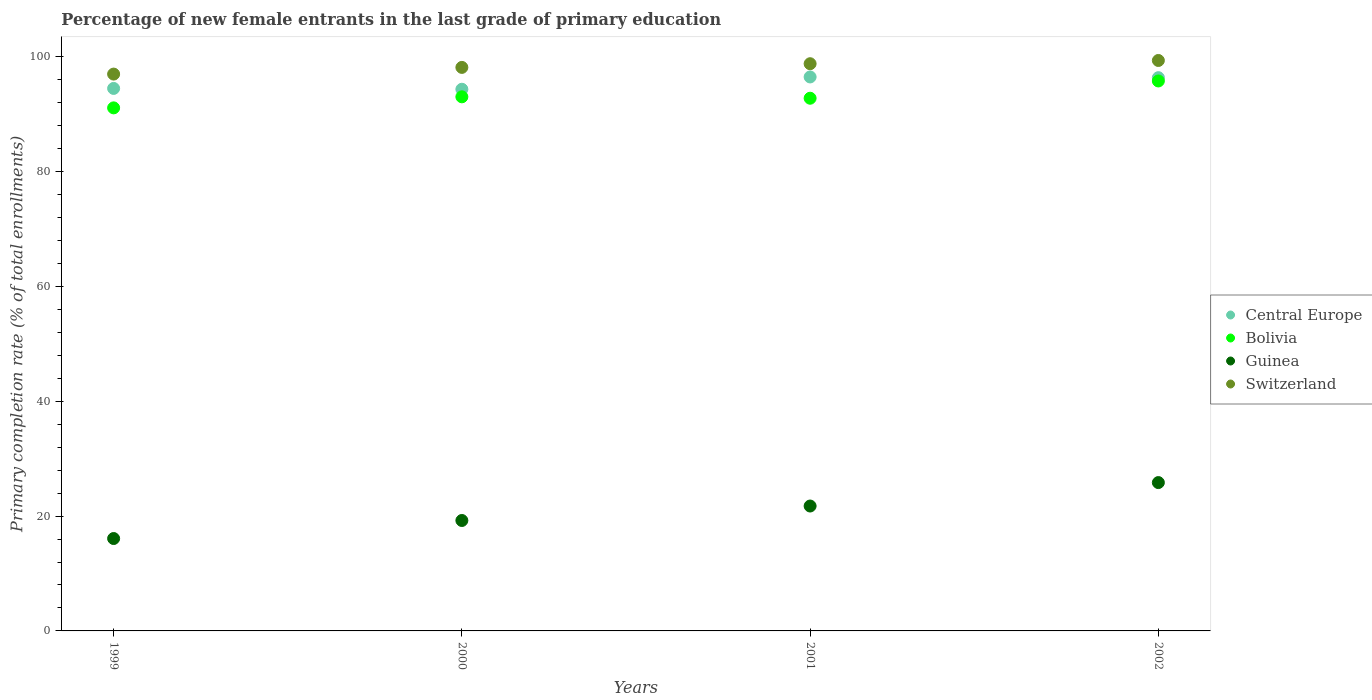What is the percentage of new female entrants in Guinea in 2001?
Provide a succinct answer. 21.75. Across all years, what is the maximum percentage of new female entrants in Guinea?
Keep it short and to the point. 25.84. Across all years, what is the minimum percentage of new female entrants in Switzerland?
Ensure brevity in your answer.  96.99. In which year was the percentage of new female entrants in Switzerland maximum?
Your answer should be very brief. 2002. In which year was the percentage of new female entrants in Guinea minimum?
Your answer should be very brief. 1999. What is the total percentage of new female entrants in Bolivia in the graph?
Give a very brief answer. 372.7. What is the difference between the percentage of new female entrants in Guinea in 1999 and that in 2001?
Your answer should be very brief. -5.66. What is the difference between the percentage of new female entrants in Bolivia in 2002 and the percentage of new female entrants in Guinea in 2000?
Your answer should be compact. 76.56. What is the average percentage of new female entrants in Bolivia per year?
Ensure brevity in your answer.  93.18. In the year 2002, what is the difference between the percentage of new female entrants in Bolivia and percentage of new female entrants in Guinea?
Make the answer very short. 69.95. In how many years, is the percentage of new female entrants in Central Europe greater than 72 %?
Offer a terse response. 4. What is the ratio of the percentage of new female entrants in Bolivia in 1999 to that in 2000?
Provide a succinct answer. 0.98. Is the difference between the percentage of new female entrants in Bolivia in 1999 and 2002 greater than the difference between the percentage of new female entrants in Guinea in 1999 and 2002?
Offer a terse response. Yes. What is the difference between the highest and the second highest percentage of new female entrants in Central Europe?
Your answer should be very brief. 0.13. What is the difference between the highest and the lowest percentage of new female entrants in Guinea?
Offer a very short reply. 9.74. In how many years, is the percentage of new female entrants in Switzerland greater than the average percentage of new female entrants in Switzerland taken over all years?
Your answer should be very brief. 2. Is the sum of the percentage of new female entrants in Bolivia in 2001 and 2002 greater than the maximum percentage of new female entrants in Central Europe across all years?
Offer a very short reply. Yes. Is the percentage of new female entrants in Bolivia strictly greater than the percentage of new female entrants in Switzerland over the years?
Offer a terse response. No. Is the percentage of new female entrants in Switzerland strictly less than the percentage of new female entrants in Guinea over the years?
Offer a very short reply. No. Does the graph contain grids?
Keep it short and to the point. No. What is the title of the graph?
Your answer should be very brief. Percentage of new female entrants in the last grade of primary education. What is the label or title of the X-axis?
Provide a succinct answer. Years. What is the label or title of the Y-axis?
Offer a terse response. Primary completion rate (% of total enrollments). What is the Primary completion rate (% of total enrollments) of Central Europe in 1999?
Provide a short and direct response. 94.49. What is the Primary completion rate (% of total enrollments) of Bolivia in 1999?
Your answer should be very brief. 91.1. What is the Primary completion rate (% of total enrollments) in Guinea in 1999?
Give a very brief answer. 16.09. What is the Primary completion rate (% of total enrollments) in Switzerland in 1999?
Make the answer very short. 96.99. What is the Primary completion rate (% of total enrollments) in Central Europe in 2000?
Provide a succinct answer. 94.35. What is the Primary completion rate (% of total enrollments) of Bolivia in 2000?
Your answer should be compact. 93.03. What is the Primary completion rate (% of total enrollments) of Guinea in 2000?
Ensure brevity in your answer.  19.23. What is the Primary completion rate (% of total enrollments) in Switzerland in 2000?
Provide a succinct answer. 98.15. What is the Primary completion rate (% of total enrollments) in Central Europe in 2001?
Provide a succinct answer. 96.49. What is the Primary completion rate (% of total enrollments) in Bolivia in 2001?
Your answer should be very brief. 92.78. What is the Primary completion rate (% of total enrollments) of Guinea in 2001?
Your response must be concise. 21.75. What is the Primary completion rate (% of total enrollments) of Switzerland in 2001?
Give a very brief answer. 98.79. What is the Primary completion rate (% of total enrollments) of Central Europe in 2002?
Provide a short and direct response. 96.36. What is the Primary completion rate (% of total enrollments) of Bolivia in 2002?
Make the answer very short. 95.79. What is the Primary completion rate (% of total enrollments) of Guinea in 2002?
Keep it short and to the point. 25.84. What is the Primary completion rate (% of total enrollments) of Switzerland in 2002?
Ensure brevity in your answer.  99.36. Across all years, what is the maximum Primary completion rate (% of total enrollments) in Central Europe?
Ensure brevity in your answer.  96.49. Across all years, what is the maximum Primary completion rate (% of total enrollments) of Bolivia?
Give a very brief answer. 95.79. Across all years, what is the maximum Primary completion rate (% of total enrollments) of Guinea?
Provide a succinct answer. 25.84. Across all years, what is the maximum Primary completion rate (% of total enrollments) in Switzerland?
Provide a succinct answer. 99.36. Across all years, what is the minimum Primary completion rate (% of total enrollments) in Central Europe?
Your response must be concise. 94.35. Across all years, what is the minimum Primary completion rate (% of total enrollments) of Bolivia?
Make the answer very short. 91.1. Across all years, what is the minimum Primary completion rate (% of total enrollments) of Guinea?
Your response must be concise. 16.09. Across all years, what is the minimum Primary completion rate (% of total enrollments) of Switzerland?
Provide a succinct answer. 96.99. What is the total Primary completion rate (% of total enrollments) of Central Europe in the graph?
Provide a short and direct response. 381.69. What is the total Primary completion rate (% of total enrollments) in Bolivia in the graph?
Ensure brevity in your answer.  372.7. What is the total Primary completion rate (% of total enrollments) in Guinea in the graph?
Your answer should be very brief. 82.92. What is the total Primary completion rate (% of total enrollments) in Switzerland in the graph?
Give a very brief answer. 393.29. What is the difference between the Primary completion rate (% of total enrollments) in Central Europe in 1999 and that in 2000?
Keep it short and to the point. 0.14. What is the difference between the Primary completion rate (% of total enrollments) of Bolivia in 1999 and that in 2000?
Your answer should be very brief. -1.93. What is the difference between the Primary completion rate (% of total enrollments) in Guinea in 1999 and that in 2000?
Keep it short and to the point. -3.14. What is the difference between the Primary completion rate (% of total enrollments) of Switzerland in 1999 and that in 2000?
Your answer should be compact. -1.16. What is the difference between the Primary completion rate (% of total enrollments) of Central Europe in 1999 and that in 2001?
Make the answer very short. -2. What is the difference between the Primary completion rate (% of total enrollments) in Bolivia in 1999 and that in 2001?
Your response must be concise. -1.68. What is the difference between the Primary completion rate (% of total enrollments) of Guinea in 1999 and that in 2001?
Offer a terse response. -5.66. What is the difference between the Primary completion rate (% of total enrollments) in Switzerland in 1999 and that in 2001?
Your response must be concise. -1.81. What is the difference between the Primary completion rate (% of total enrollments) of Central Europe in 1999 and that in 2002?
Offer a very short reply. -1.87. What is the difference between the Primary completion rate (% of total enrollments) in Bolivia in 1999 and that in 2002?
Your response must be concise. -4.69. What is the difference between the Primary completion rate (% of total enrollments) in Guinea in 1999 and that in 2002?
Your answer should be very brief. -9.74. What is the difference between the Primary completion rate (% of total enrollments) of Switzerland in 1999 and that in 2002?
Your answer should be compact. -2.37. What is the difference between the Primary completion rate (% of total enrollments) in Central Europe in 2000 and that in 2001?
Ensure brevity in your answer.  -2.14. What is the difference between the Primary completion rate (% of total enrollments) of Bolivia in 2000 and that in 2001?
Your answer should be very brief. 0.25. What is the difference between the Primary completion rate (% of total enrollments) of Guinea in 2000 and that in 2001?
Give a very brief answer. -2.52. What is the difference between the Primary completion rate (% of total enrollments) in Switzerland in 2000 and that in 2001?
Offer a terse response. -0.64. What is the difference between the Primary completion rate (% of total enrollments) in Central Europe in 2000 and that in 2002?
Make the answer very short. -2.02. What is the difference between the Primary completion rate (% of total enrollments) of Bolivia in 2000 and that in 2002?
Offer a very short reply. -2.76. What is the difference between the Primary completion rate (% of total enrollments) of Guinea in 2000 and that in 2002?
Your answer should be very brief. -6.6. What is the difference between the Primary completion rate (% of total enrollments) of Switzerland in 2000 and that in 2002?
Offer a terse response. -1.21. What is the difference between the Primary completion rate (% of total enrollments) of Central Europe in 2001 and that in 2002?
Your answer should be compact. 0.13. What is the difference between the Primary completion rate (% of total enrollments) in Bolivia in 2001 and that in 2002?
Your response must be concise. -3.01. What is the difference between the Primary completion rate (% of total enrollments) of Guinea in 2001 and that in 2002?
Give a very brief answer. -4.08. What is the difference between the Primary completion rate (% of total enrollments) of Switzerland in 2001 and that in 2002?
Offer a very short reply. -0.56. What is the difference between the Primary completion rate (% of total enrollments) in Central Europe in 1999 and the Primary completion rate (% of total enrollments) in Bolivia in 2000?
Give a very brief answer. 1.46. What is the difference between the Primary completion rate (% of total enrollments) of Central Europe in 1999 and the Primary completion rate (% of total enrollments) of Guinea in 2000?
Keep it short and to the point. 75.26. What is the difference between the Primary completion rate (% of total enrollments) in Central Europe in 1999 and the Primary completion rate (% of total enrollments) in Switzerland in 2000?
Keep it short and to the point. -3.66. What is the difference between the Primary completion rate (% of total enrollments) in Bolivia in 1999 and the Primary completion rate (% of total enrollments) in Guinea in 2000?
Ensure brevity in your answer.  71.87. What is the difference between the Primary completion rate (% of total enrollments) in Bolivia in 1999 and the Primary completion rate (% of total enrollments) in Switzerland in 2000?
Your answer should be compact. -7.05. What is the difference between the Primary completion rate (% of total enrollments) in Guinea in 1999 and the Primary completion rate (% of total enrollments) in Switzerland in 2000?
Provide a succinct answer. -82.06. What is the difference between the Primary completion rate (% of total enrollments) of Central Europe in 1999 and the Primary completion rate (% of total enrollments) of Bolivia in 2001?
Keep it short and to the point. 1.71. What is the difference between the Primary completion rate (% of total enrollments) in Central Europe in 1999 and the Primary completion rate (% of total enrollments) in Guinea in 2001?
Your response must be concise. 72.74. What is the difference between the Primary completion rate (% of total enrollments) of Central Europe in 1999 and the Primary completion rate (% of total enrollments) of Switzerland in 2001?
Offer a terse response. -4.3. What is the difference between the Primary completion rate (% of total enrollments) of Bolivia in 1999 and the Primary completion rate (% of total enrollments) of Guinea in 2001?
Offer a very short reply. 69.35. What is the difference between the Primary completion rate (% of total enrollments) in Bolivia in 1999 and the Primary completion rate (% of total enrollments) in Switzerland in 2001?
Provide a short and direct response. -7.69. What is the difference between the Primary completion rate (% of total enrollments) of Guinea in 1999 and the Primary completion rate (% of total enrollments) of Switzerland in 2001?
Your response must be concise. -82.7. What is the difference between the Primary completion rate (% of total enrollments) in Central Europe in 1999 and the Primary completion rate (% of total enrollments) in Bolivia in 2002?
Keep it short and to the point. -1.3. What is the difference between the Primary completion rate (% of total enrollments) of Central Europe in 1999 and the Primary completion rate (% of total enrollments) of Guinea in 2002?
Give a very brief answer. 68.65. What is the difference between the Primary completion rate (% of total enrollments) in Central Europe in 1999 and the Primary completion rate (% of total enrollments) in Switzerland in 2002?
Ensure brevity in your answer.  -4.87. What is the difference between the Primary completion rate (% of total enrollments) of Bolivia in 1999 and the Primary completion rate (% of total enrollments) of Guinea in 2002?
Offer a terse response. 65.27. What is the difference between the Primary completion rate (% of total enrollments) in Bolivia in 1999 and the Primary completion rate (% of total enrollments) in Switzerland in 2002?
Provide a succinct answer. -8.25. What is the difference between the Primary completion rate (% of total enrollments) in Guinea in 1999 and the Primary completion rate (% of total enrollments) in Switzerland in 2002?
Your response must be concise. -83.27. What is the difference between the Primary completion rate (% of total enrollments) of Central Europe in 2000 and the Primary completion rate (% of total enrollments) of Bolivia in 2001?
Provide a short and direct response. 1.56. What is the difference between the Primary completion rate (% of total enrollments) of Central Europe in 2000 and the Primary completion rate (% of total enrollments) of Guinea in 2001?
Provide a short and direct response. 72.59. What is the difference between the Primary completion rate (% of total enrollments) in Central Europe in 2000 and the Primary completion rate (% of total enrollments) in Switzerland in 2001?
Make the answer very short. -4.45. What is the difference between the Primary completion rate (% of total enrollments) in Bolivia in 2000 and the Primary completion rate (% of total enrollments) in Guinea in 2001?
Your response must be concise. 71.27. What is the difference between the Primary completion rate (% of total enrollments) in Bolivia in 2000 and the Primary completion rate (% of total enrollments) in Switzerland in 2001?
Your answer should be compact. -5.77. What is the difference between the Primary completion rate (% of total enrollments) of Guinea in 2000 and the Primary completion rate (% of total enrollments) of Switzerland in 2001?
Keep it short and to the point. -79.56. What is the difference between the Primary completion rate (% of total enrollments) of Central Europe in 2000 and the Primary completion rate (% of total enrollments) of Bolivia in 2002?
Keep it short and to the point. -1.44. What is the difference between the Primary completion rate (% of total enrollments) in Central Europe in 2000 and the Primary completion rate (% of total enrollments) in Guinea in 2002?
Your answer should be compact. 68.51. What is the difference between the Primary completion rate (% of total enrollments) in Central Europe in 2000 and the Primary completion rate (% of total enrollments) in Switzerland in 2002?
Your response must be concise. -5.01. What is the difference between the Primary completion rate (% of total enrollments) in Bolivia in 2000 and the Primary completion rate (% of total enrollments) in Guinea in 2002?
Your response must be concise. 67.19. What is the difference between the Primary completion rate (% of total enrollments) in Bolivia in 2000 and the Primary completion rate (% of total enrollments) in Switzerland in 2002?
Ensure brevity in your answer.  -6.33. What is the difference between the Primary completion rate (% of total enrollments) of Guinea in 2000 and the Primary completion rate (% of total enrollments) of Switzerland in 2002?
Keep it short and to the point. -80.12. What is the difference between the Primary completion rate (% of total enrollments) of Central Europe in 2001 and the Primary completion rate (% of total enrollments) of Bolivia in 2002?
Keep it short and to the point. 0.7. What is the difference between the Primary completion rate (% of total enrollments) in Central Europe in 2001 and the Primary completion rate (% of total enrollments) in Guinea in 2002?
Offer a very short reply. 70.65. What is the difference between the Primary completion rate (% of total enrollments) in Central Europe in 2001 and the Primary completion rate (% of total enrollments) in Switzerland in 2002?
Provide a succinct answer. -2.87. What is the difference between the Primary completion rate (% of total enrollments) in Bolivia in 2001 and the Primary completion rate (% of total enrollments) in Guinea in 2002?
Your response must be concise. 66.95. What is the difference between the Primary completion rate (% of total enrollments) in Bolivia in 2001 and the Primary completion rate (% of total enrollments) in Switzerland in 2002?
Your answer should be compact. -6.58. What is the difference between the Primary completion rate (% of total enrollments) in Guinea in 2001 and the Primary completion rate (% of total enrollments) in Switzerland in 2002?
Provide a succinct answer. -77.6. What is the average Primary completion rate (% of total enrollments) in Central Europe per year?
Your response must be concise. 95.42. What is the average Primary completion rate (% of total enrollments) in Bolivia per year?
Your answer should be compact. 93.18. What is the average Primary completion rate (% of total enrollments) in Guinea per year?
Provide a succinct answer. 20.73. What is the average Primary completion rate (% of total enrollments) in Switzerland per year?
Ensure brevity in your answer.  98.32. In the year 1999, what is the difference between the Primary completion rate (% of total enrollments) in Central Europe and Primary completion rate (% of total enrollments) in Bolivia?
Provide a short and direct response. 3.39. In the year 1999, what is the difference between the Primary completion rate (% of total enrollments) of Central Europe and Primary completion rate (% of total enrollments) of Guinea?
Make the answer very short. 78.4. In the year 1999, what is the difference between the Primary completion rate (% of total enrollments) in Central Europe and Primary completion rate (% of total enrollments) in Switzerland?
Give a very brief answer. -2.5. In the year 1999, what is the difference between the Primary completion rate (% of total enrollments) in Bolivia and Primary completion rate (% of total enrollments) in Guinea?
Your answer should be compact. 75.01. In the year 1999, what is the difference between the Primary completion rate (% of total enrollments) in Bolivia and Primary completion rate (% of total enrollments) in Switzerland?
Your answer should be very brief. -5.88. In the year 1999, what is the difference between the Primary completion rate (% of total enrollments) in Guinea and Primary completion rate (% of total enrollments) in Switzerland?
Offer a terse response. -80.89. In the year 2000, what is the difference between the Primary completion rate (% of total enrollments) of Central Europe and Primary completion rate (% of total enrollments) of Bolivia?
Provide a short and direct response. 1.32. In the year 2000, what is the difference between the Primary completion rate (% of total enrollments) of Central Europe and Primary completion rate (% of total enrollments) of Guinea?
Provide a short and direct response. 75.11. In the year 2000, what is the difference between the Primary completion rate (% of total enrollments) in Central Europe and Primary completion rate (% of total enrollments) in Switzerland?
Offer a very short reply. -3.81. In the year 2000, what is the difference between the Primary completion rate (% of total enrollments) of Bolivia and Primary completion rate (% of total enrollments) of Guinea?
Provide a short and direct response. 73.79. In the year 2000, what is the difference between the Primary completion rate (% of total enrollments) of Bolivia and Primary completion rate (% of total enrollments) of Switzerland?
Provide a succinct answer. -5.12. In the year 2000, what is the difference between the Primary completion rate (% of total enrollments) in Guinea and Primary completion rate (% of total enrollments) in Switzerland?
Your response must be concise. -78.92. In the year 2001, what is the difference between the Primary completion rate (% of total enrollments) in Central Europe and Primary completion rate (% of total enrollments) in Bolivia?
Keep it short and to the point. 3.71. In the year 2001, what is the difference between the Primary completion rate (% of total enrollments) of Central Europe and Primary completion rate (% of total enrollments) of Guinea?
Your answer should be compact. 74.73. In the year 2001, what is the difference between the Primary completion rate (% of total enrollments) of Central Europe and Primary completion rate (% of total enrollments) of Switzerland?
Ensure brevity in your answer.  -2.31. In the year 2001, what is the difference between the Primary completion rate (% of total enrollments) of Bolivia and Primary completion rate (% of total enrollments) of Guinea?
Provide a succinct answer. 71.03. In the year 2001, what is the difference between the Primary completion rate (% of total enrollments) in Bolivia and Primary completion rate (% of total enrollments) in Switzerland?
Give a very brief answer. -6.01. In the year 2001, what is the difference between the Primary completion rate (% of total enrollments) of Guinea and Primary completion rate (% of total enrollments) of Switzerland?
Keep it short and to the point. -77.04. In the year 2002, what is the difference between the Primary completion rate (% of total enrollments) in Central Europe and Primary completion rate (% of total enrollments) in Bolivia?
Your response must be concise. 0.57. In the year 2002, what is the difference between the Primary completion rate (% of total enrollments) in Central Europe and Primary completion rate (% of total enrollments) in Guinea?
Provide a short and direct response. 70.53. In the year 2002, what is the difference between the Primary completion rate (% of total enrollments) in Central Europe and Primary completion rate (% of total enrollments) in Switzerland?
Your answer should be very brief. -3. In the year 2002, what is the difference between the Primary completion rate (% of total enrollments) of Bolivia and Primary completion rate (% of total enrollments) of Guinea?
Your response must be concise. 69.95. In the year 2002, what is the difference between the Primary completion rate (% of total enrollments) in Bolivia and Primary completion rate (% of total enrollments) in Switzerland?
Offer a terse response. -3.57. In the year 2002, what is the difference between the Primary completion rate (% of total enrollments) of Guinea and Primary completion rate (% of total enrollments) of Switzerland?
Give a very brief answer. -73.52. What is the ratio of the Primary completion rate (% of total enrollments) of Central Europe in 1999 to that in 2000?
Make the answer very short. 1. What is the ratio of the Primary completion rate (% of total enrollments) in Bolivia in 1999 to that in 2000?
Your answer should be compact. 0.98. What is the ratio of the Primary completion rate (% of total enrollments) in Guinea in 1999 to that in 2000?
Your answer should be compact. 0.84. What is the ratio of the Primary completion rate (% of total enrollments) in Central Europe in 1999 to that in 2001?
Ensure brevity in your answer.  0.98. What is the ratio of the Primary completion rate (% of total enrollments) in Bolivia in 1999 to that in 2001?
Provide a succinct answer. 0.98. What is the ratio of the Primary completion rate (% of total enrollments) in Guinea in 1999 to that in 2001?
Ensure brevity in your answer.  0.74. What is the ratio of the Primary completion rate (% of total enrollments) in Switzerland in 1999 to that in 2001?
Make the answer very short. 0.98. What is the ratio of the Primary completion rate (% of total enrollments) in Central Europe in 1999 to that in 2002?
Your answer should be very brief. 0.98. What is the ratio of the Primary completion rate (% of total enrollments) in Bolivia in 1999 to that in 2002?
Provide a succinct answer. 0.95. What is the ratio of the Primary completion rate (% of total enrollments) in Guinea in 1999 to that in 2002?
Offer a terse response. 0.62. What is the ratio of the Primary completion rate (% of total enrollments) of Switzerland in 1999 to that in 2002?
Make the answer very short. 0.98. What is the ratio of the Primary completion rate (% of total enrollments) of Central Europe in 2000 to that in 2001?
Ensure brevity in your answer.  0.98. What is the ratio of the Primary completion rate (% of total enrollments) in Bolivia in 2000 to that in 2001?
Your answer should be very brief. 1. What is the ratio of the Primary completion rate (% of total enrollments) of Guinea in 2000 to that in 2001?
Offer a terse response. 0.88. What is the ratio of the Primary completion rate (% of total enrollments) in Switzerland in 2000 to that in 2001?
Your response must be concise. 0.99. What is the ratio of the Primary completion rate (% of total enrollments) of Central Europe in 2000 to that in 2002?
Provide a succinct answer. 0.98. What is the ratio of the Primary completion rate (% of total enrollments) in Bolivia in 2000 to that in 2002?
Your answer should be compact. 0.97. What is the ratio of the Primary completion rate (% of total enrollments) of Guinea in 2000 to that in 2002?
Give a very brief answer. 0.74. What is the ratio of the Primary completion rate (% of total enrollments) in Switzerland in 2000 to that in 2002?
Give a very brief answer. 0.99. What is the ratio of the Primary completion rate (% of total enrollments) of Central Europe in 2001 to that in 2002?
Give a very brief answer. 1. What is the ratio of the Primary completion rate (% of total enrollments) of Bolivia in 2001 to that in 2002?
Provide a succinct answer. 0.97. What is the ratio of the Primary completion rate (% of total enrollments) in Guinea in 2001 to that in 2002?
Give a very brief answer. 0.84. What is the difference between the highest and the second highest Primary completion rate (% of total enrollments) of Central Europe?
Ensure brevity in your answer.  0.13. What is the difference between the highest and the second highest Primary completion rate (% of total enrollments) of Bolivia?
Provide a succinct answer. 2.76. What is the difference between the highest and the second highest Primary completion rate (% of total enrollments) in Guinea?
Offer a very short reply. 4.08. What is the difference between the highest and the second highest Primary completion rate (% of total enrollments) in Switzerland?
Offer a very short reply. 0.56. What is the difference between the highest and the lowest Primary completion rate (% of total enrollments) of Central Europe?
Ensure brevity in your answer.  2.14. What is the difference between the highest and the lowest Primary completion rate (% of total enrollments) in Bolivia?
Provide a short and direct response. 4.69. What is the difference between the highest and the lowest Primary completion rate (% of total enrollments) of Guinea?
Your answer should be compact. 9.74. What is the difference between the highest and the lowest Primary completion rate (% of total enrollments) of Switzerland?
Offer a very short reply. 2.37. 